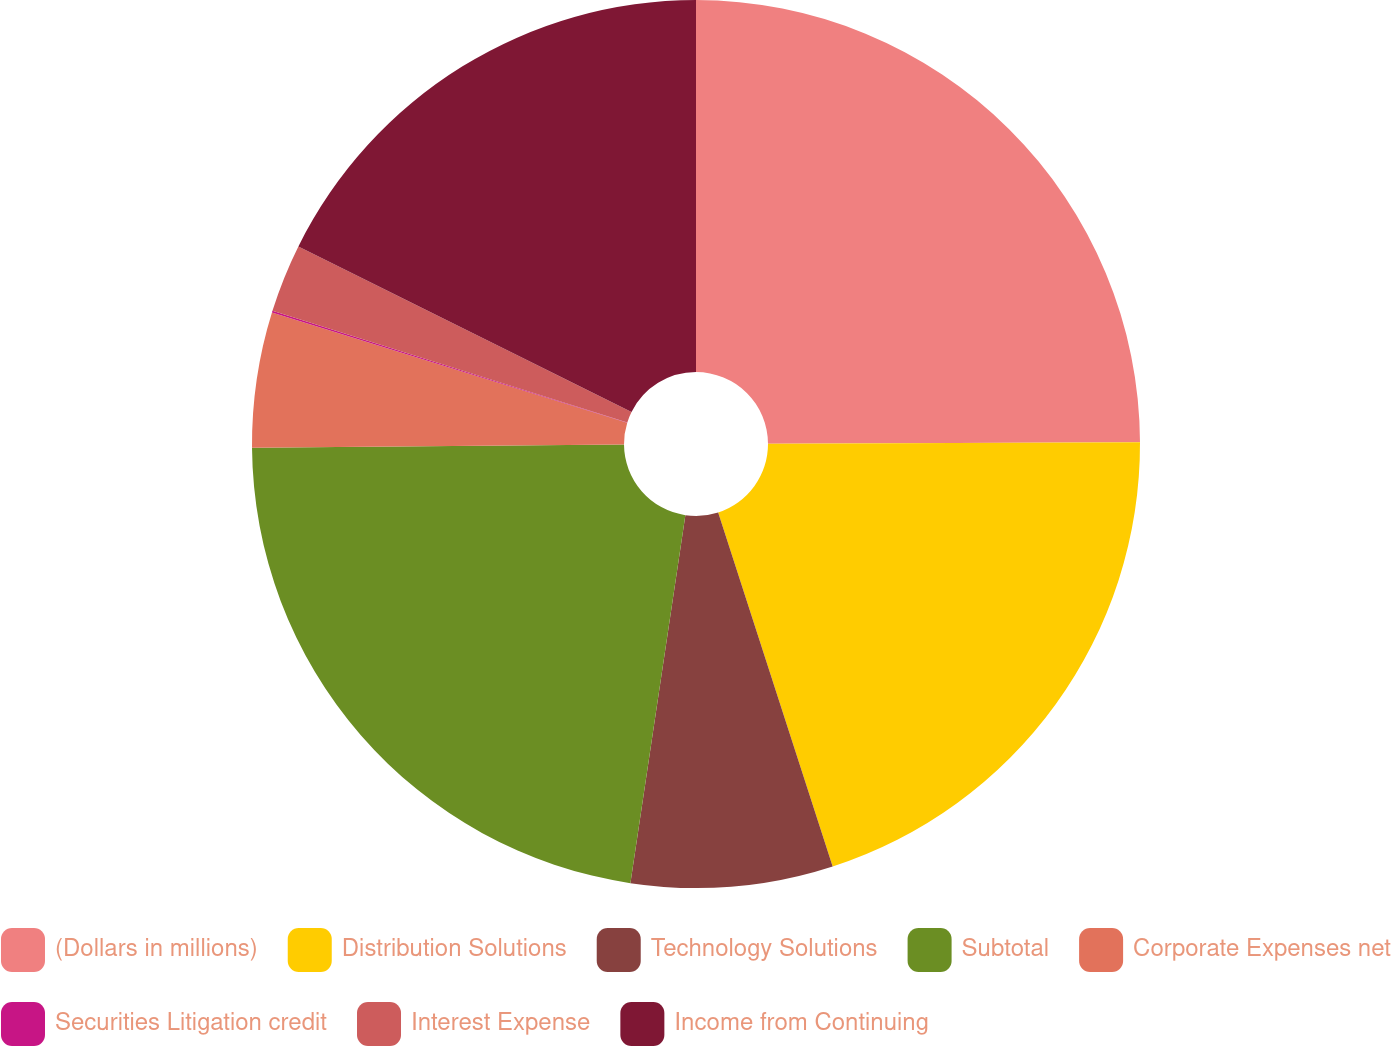<chart> <loc_0><loc_0><loc_500><loc_500><pie_chart><fcel>(Dollars in millions)<fcel>Distribution Solutions<fcel>Technology Solutions<fcel>Subtotal<fcel>Corporate Expenses net<fcel>Securities Litigation credit<fcel>Interest Expense<fcel>Income from Continuing<nl><fcel>24.94%<fcel>20.08%<fcel>7.34%<fcel>22.51%<fcel>4.92%<fcel>0.06%<fcel>2.49%<fcel>17.66%<nl></chart> 